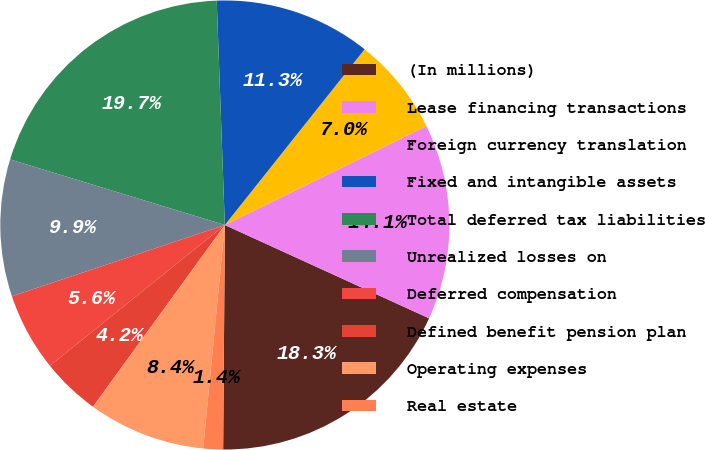Convert chart. <chart><loc_0><loc_0><loc_500><loc_500><pie_chart><fcel>(In millions)<fcel>Lease financing transactions<fcel>Foreign currency translation<fcel>Fixed and intangible assets<fcel>Total deferred tax liabilities<fcel>Unrealized losses on<fcel>Deferred compensation<fcel>Defined benefit pension plan<fcel>Operating expenses<fcel>Real estate<nl><fcel>18.3%<fcel>14.08%<fcel>7.05%<fcel>11.27%<fcel>19.71%<fcel>9.86%<fcel>5.64%<fcel>4.23%<fcel>8.45%<fcel>1.42%<nl></chart> 